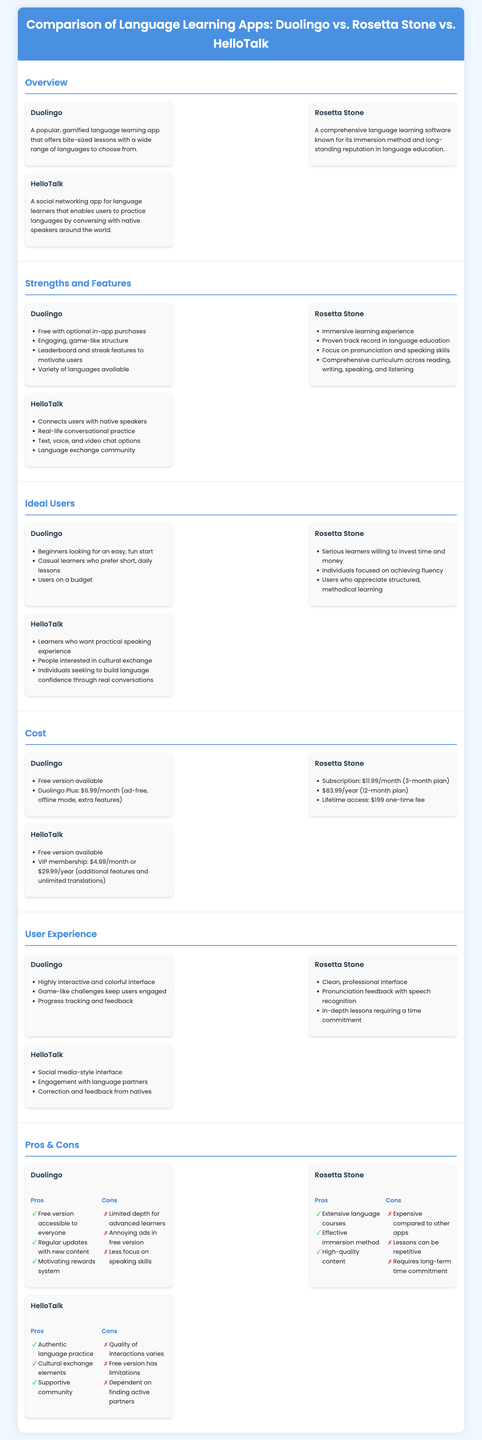What is the main focus of Duolingo? Duolingo is a popular, gamified language learning app that offers bite-sized lessons with a wide range of languages to choose from.
Answer: Gamified language learning What is the subscription cost of Rosetta Stone for a 12-month plan? The subscription cost for Rosetta Stone is outlined in the document, stating $83.99 for a 12-month plan.
Answer: $83.99/year Who is the ideal user for HelloTalk? The document specifies that ideal users for HelloTalk are those who seek practical speaking experience, cultural exchange, and confidence in conversations.
Answer: Practical speaking experience How does Duolingo motivate users? Duolingo motivates users through a leaderboard and streak features in combination with a rewarding game-like structure.
Answer: Leaderboard and streak features What is a notable pro of using Rosetta Stone? One notable pro of Rosetta Stone is its extensive language courses, making it effective for serious learners.
Answer: Extensive language courses What key feature distinguishes HelloTalk from the other apps? HelloTalk is distinguished by its ability to connect users with native speakers for real-life conversational practice.
Answer: Connects users with native speakers What year was the Rosetta Stone language software known for its immersion method? The document does not specify a year; it only mentions Rosetta Stone's long-standing reputation in language education.
Answer: Long-standing reputation What type of user experience does Duolingo provide? Duolingo provides a highly interactive and colorful interface, enhancing user engagement through game-like challenges.
Answer: Interactive and colorful interface 